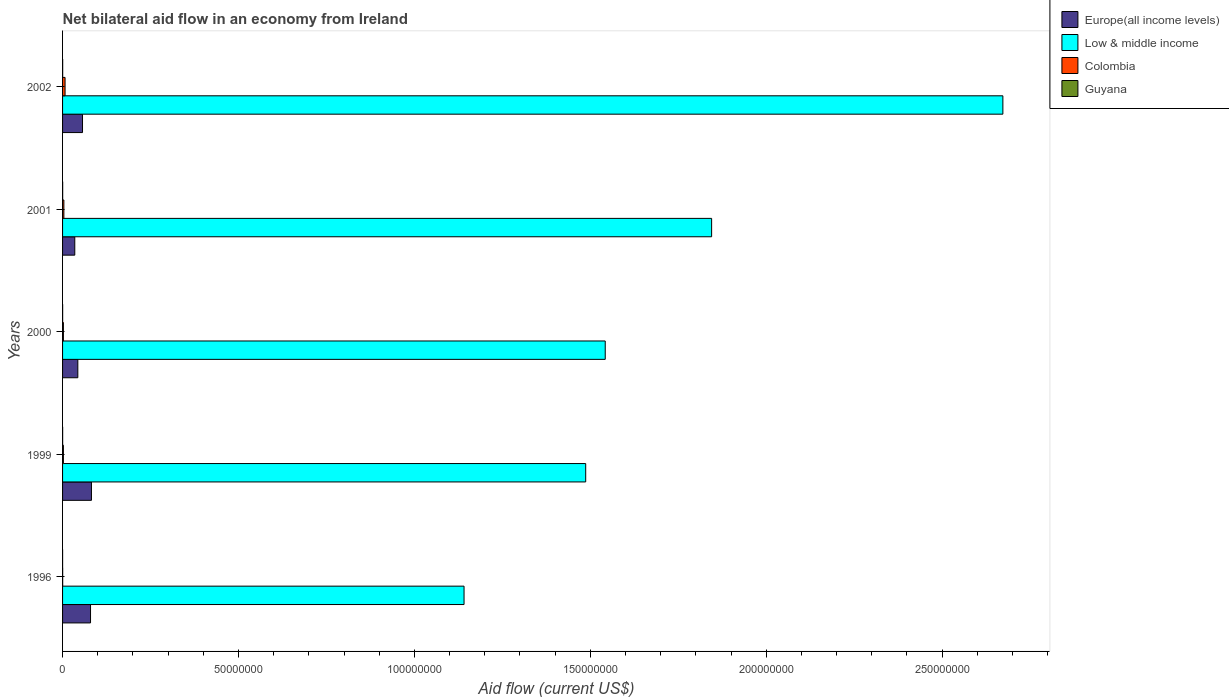How many different coloured bars are there?
Make the answer very short. 4. How many groups of bars are there?
Make the answer very short. 5. Are the number of bars on each tick of the Y-axis equal?
Provide a short and direct response. Yes. How many bars are there on the 2nd tick from the top?
Your answer should be compact. 4. In how many cases, is the number of bars for a given year not equal to the number of legend labels?
Make the answer very short. 0. What is the net bilateral aid flow in Europe(all income levels) in 1999?
Ensure brevity in your answer.  8.21e+06. Across all years, what is the maximum net bilateral aid flow in Low & middle income?
Provide a short and direct response. 2.67e+08. Across all years, what is the minimum net bilateral aid flow in Europe(all income levels)?
Offer a very short reply. 3.47e+06. In which year was the net bilateral aid flow in Guyana minimum?
Offer a terse response. 1996. What is the total net bilateral aid flow in Europe(all income levels) in the graph?
Provide a short and direct response. 2.96e+07. What is the difference between the net bilateral aid flow in Europe(all income levels) in 1996 and the net bilateral aid flow in Guyana in 2000?
Give a very brief answer. 7.93e+06. What is the average net bilateral aid flow in Guyana per year?
Offer a terse response. 2.20e+04. In the year 1999, what is the difference between the net bilateral aid flow in Guyana and net bilateral aid flow in Europe(all income levels)?
Give a very brief answer. -8.19e+06. What is the ratio of the net bilateral aid flow in Europe(all income levels) in 1999 to that in 2002?
Make the answer very short. 1.45. Is the net bilateral aid flow in Guyana in 1999 less than that in 2000?
Provide a short and direct response. No. What is the difference between the highest and the lowest net bilateral aid flow in Low & middle income?
Provide a succinct answer. 1.53e+08. In how many years, is the net bilateral aid flow in Low & middle income greater than the average net bilateral aid flow in Low & middle income taken over all years?
Make the answer very short. 2. Is the sum of the net bilateral aid flow in Europe(all income levels) in 1996 and 1999 greater than the maximum net bilateral aid flow in Colombia across all years?
Provide a short and direct response. Yes. How many bars are there?
Your answer should be compact. 20. What is the difference between two consecutive major ticks on the X-axis?
Give a very brief answer. 5.00e+07. Are the values on the major ticks of X-axis written in scientific E-notation?
Offer a terse response. No. What is the title of the graph?
Offer a very short reply. Net bilateral aid flow in an economy from Ireland. Does "Greenland" appear as one of the legend labels in the graph?
Your answer should be very brief. No. What is the label or title of the Y-axis?
Make the answer very short. Years. What is the Aid flow (current US$) of Europe(all income levels) in 1996?
Make the answer very short. 7.95e+06. What is the Aid flow (current US$) of Low & middle income in 1996?
Your answer should be compact. 1.14e+08. What is the Aid flow (current US$) of Guyana in 1996?
Offer a very short reply. 10000. What is the Aid flow (current US$) of Europe(all income levels) in 1999?
Offer a very short reply. 8.21e+06. What is the Aid flow (current US$) in Low & middle income in 1999?
Ensure brevity in your answer.  1.49e+08. What is the Aid flow (current US$) in Colombia in 1999?
Keep it short and to the point. 2.40e+05. What is the Aid flow (current US$) in Europe(all income levels) in 2000?
Your answer should be compact. 4.34e+06. What is the Aid flow (current US$) of Low & middle income in 2000?
Give a very brief answer. 1.54e+08. What is the Aid flow (current US$) of Europe(all income levels) in 2001?
Your answer should be very brief. 3.47e+06. What is the Aid flow (current US$) of Low & middle income in 2001?
Keep it short and to the point. 1.84e+08. What is the Aid flow (current US$) in Europe(all income levels) in 2002?
Keep it short and to the point. 5.67e+06. What is the Aid flow (current US$) in Low & middle income in 2002?
Ensure brevity in your answer.  2.67e+08. What is the Aid flow (current US$) in Colombia in 2002?
Your answer should be very brief. 7.10e+05. Across all years, what is the maximum Aid flow (current US$) in Europe(all income levels)?
Ensure brevity in your answer.  8.21e+06. Across all years, what is the maximum Aid flow (current US$) of Low & middle income?
Your answer should be compact. 2.67e+08. Across all years, what is the maximum Aid flow (current US$) of Colombia?
Your response must be concise. 7.10e+05. Across all years, what is the maximum Aid flow (current US$) of Guyana?
Ensure brevity in your answer.  3.00e+04. Across all years, what is the minimum Aid flow (current US$) in Europe(all income levels)?
Make the answer very short. 3.47e+06. Across all years, what is the minimum Aid flow (current US$) in Low & middle income?
Offer a very short reply. 1.14e+08. Across all years, what is the minimum Aid flow (current US$) in Colombia?
Make the answer very short. 3.00e+04. Across all years, what is the minimum Aid flow (current US$) of Guyana?
Provide a short and direct response. 10000. What is the total Aid flow (current US$) in Europe(all income levels) in the graph?
Your response must be concise. 2.96e+07. What is the total Aid flow (current US$) in Low & middle income in the graph?
Provide a succinct answer. 8.69e+08. What is the total Aid flow (current US$) in Colombia in the graph?
Your response must be concise. 1.59e+06. What is the total Aid flow (current US$) in Guyana in the graph?
Your answer should be compact. 1.10e+05. What is the difference between the Aid flow (current US$) of Europe(all income levels) in 1996 and that in 1999?
Your answer should be compact. -2.60e+05. What is the difference between the Aid flow (current US$) in Low & middle income in 1996 and that in 1999?
Your response must be concise. -3.46e+07. What is the difference between the Aid flow (current US$) of Europe(all income levels) in 1996 and that in 2000?
Provide a short and direct response. 3.61e+06. What is the difference between the Aid flow (current US$) of Low & middle income in 1996 and that in 2000?
Provide a short and direct response. -4.01e+07. What is the difference between the Aid flow (current US$) of Europe(all income levels) in 1996 and that in 2001?
Offer a very short reply. 4.48e+06. What is the difference between the Aid flow (current US$) in Low & middle income in 1996 and that in 2001?
Provide a succinct answer. -7.04e+07. What is the difference between the Aid flow (current US$) in Colombia in 1996 and that in 2001?
Ensure brevity in your answer.  -3.40e+05. What is the difference between the Aid flow (current US$) of Europe(all income levels) in 1996 and that in 2002?
Ensure brevity in your answer.  2.28e+06. What is the difference between the Aid flow (current US$) in Low & middle income in 1996 and that in 2002?
Give a very brief answer. -1.53e+08. What is the difference between the Aid flow (current US$) in Colombia in 1996 and that in 2002?
Your answer should be compact. -6.80e+05. What is the difference between the Aid flow (current US$) of Europe(all income levels) in 1999 and that in 2000?
Keep it short and to the point. 3.87e+06. What is the difference between the Aid flow (current US$) in Low & middle income in 1999 and that in 2000?
Keep it short and to the point. -5.55e+06. What is the difference between the Aid flow (current US$) of Europe(all income levels) in 1999 and that in 2001?
Make the answer very short. 4.74e+06. What is the difference between the Aid flow (current US$) in Low & middle income in 1999 and that in 2001?
Your answer should be compact. -3.58e+07. What is the difference between the Aid flow (current US$) of Colombia in 1999 and that in 2001?
Give a very brief answer. -1.30e+05. What is the difference between the Aid flow (current US$) of Europe(all income levels) in 1999 and that in 2002?
Your answer should be very brief. 2.54e+06. What is the difference between the Aid flow (current US$) of Low & middle income in 1999 and that in 2002?
Give a very brief answer. -1.19e+08. What is the difference between the Aid flow (current US$) in Colombia in 1999 and that in 2002?
Your answer should be very brief. -4.70e+05. What is the difference between the Aid flow (current US$) in Europe(all income levels) in 2000 and that in 2001?
Your answer should be compact. 8.70e+05. What is the difference between the Aid flow (current US$) of Low & middle income in 2000 and that in 2001?
Your answer should be very brief. -3.02e+07. What is the difference between the Aid flow (current US$) of Europe(all income levels) in 2000 and that in 2002?
Your response must be concise. -1.33e+06. What is the difference between the Aid flow (current US$) of Low & middle income in 2000 and that in 2002?
Your answer should be compact. -1.13e+08. What is the difference between the Aid flow (current US$) of Colombia in 2000 and that in 2002?
Your response must be concise. -4.70e+05. What is the difference between the Aid flow (current US$) in Europe(all income levels) in 2001 and that in 2002?
Ensure brevity in your answer.  -2.20e+06. What is the difference between the Aid flow (current US$) in Low & middle income in 2001 and that in 2002?
Provide a short and direct response. -8.28e+07. What is the difference between the Aid flow (current US$) of Colombia in 2001 and that in 2002?
Provide a succinct answer. -3.40e+05. What is the difference between the Aid flow (current US$) of Europe(all income levels) in 1996 and the Aid flow (current US$) of Low & middle income in 1999?
Give a very brief answer. -1.41e+08. What is the difference between the Aid flow (current US$) in Europe(all income levels) in 1996 and the Aid flow (current US$) in Colombia in 1999?
Offer a terse response. 7.71e+06. What is the difference between the Aid flow (current US$) in Europe(all income levels) in 1996 and the Aid flow (current US$) in Guyana in 1999?
Provide a succinct answer. 7.93e+06. What is the difference between the Aid flow (current US$) in Low & middle income in 1996 and the Aid flow (current US$) in Colombia in 1999?
Make the answer very short. 1.14e+08. What is the difference between the Aid flow (current US$) of Low & middle income in 1996 and the Aid flow (current US$) of Guyana in 1999?
Make the answer very short. 1.14e+08. What is the difference between the Aid flow (current US$) of Europe(all income levels) in 1996 and the Aid flow (current US$) of Low & middle income in 2000?
Ensure brevity in your answer.  -1.46e+08. What is the difference between the Aid flow (current US$) of Europe(all income levels) in 1996 and the Aid flow (current US$) of Colombia in 2000?
Your answer should be compact. 7.71e+06. What is the difference between the Aid flow (current US$) in Europe(all income levels) in 1996 and the Aid flow (current US$) in Guyana in 2000?
Provide a short and direct response. 7.93e+06. What is the difference between the Aid flow (current US$) in Low & middle income in 1996 and the Aid flow (current US$) in Colombia in 2000?
Provide a short and direct response. 1.14e+08. What is the difference between the Aid flow (current US$) in Low & middle income in 1996 and the Aid flow (current US$) in Guyana in 2000?
Provide a succinct answer. 1.14e+08. What is the difference between the Aid flow (current US$) of Colombia in 1996 and the Aid flow (current US$) of Guyana in 2000?
Keep it short and to the point. 10000. What is the difference between the Aid flow (current US$) in Europe(all income levels) in 1996 and the Aid flow (current US$) in Low & middle income in 2001?
Your answer should be compact. -1.77e+08. What is the difference between the Aid flow (current US$) in Europe(all income levels) in 1996 and the Aid flow (current US$) in Colombia in 2001?
Make the answer very short. 7.58e+06. What is the difference between the Aid flow (current US$) in Europe(all income levels) in 1996 and the Aid flow (current US$) in Guyana in 2001?
Provide a succinct answer. 7.92e+06. What is the difference between the Aid flow (current US$) in Low & middle income in 1996 and the Aid flow (current US$) in Colombia in 2001?
Make the answer very short. 1.14e+08. What is the difference between the Aid flow (current US$) of Low & middle income in 1996 and the Aid flow (current US$) of Guyana in 2001?
Provide a short and direct response. 1.14e+08. What is the difference between the Aid flow (current US$) in Colombia in 1996 and the Aid flow (current US$) in Guyana in 2001?
Give a very brief answer. 0. What is the difference between the Aid flow (current US$) in Europe(all income levels) in 1996 and the Aid flow (current US$) in Low & middle income in 2002?
Make the answer very short. -2.59e+08. What is the difference between the Aid flow (current US$) of Europe(all income levels) in 1996 and the Aid flow (current US$) of Colombia in 2002?
Offer a terse response. 7.24e+06. What is the difference between the Aid flow (current US$) of Europe(all income levels) in 1996 and the Aid flow (current US$) of Guyana in 2002?
Make the answer very short. 7.92e+06. What is the difference between the Aid flow (current US$) of Low & middle income in 1996 and the Aid flow (current US$) of Colombia in 2002?
Give a very brief answer. 1.13e+08. What is the difference between the Aid flow (current US$) in Low & middle income in 1996 and the Aid flow (current US$) in Guyana in 2002?
Give a very brief answer. 1.14e+08. What is the difference between the Aid flow (current US$) in Europe(all income levels) in 1999 and the Aid flow (current US$) in Low & middle income in 2000?
Ensure brevity in your answer.  -1.46e+08. What is the difference between the Aid flow (current US$) of Europe(all income levels) in 1999 and the Aid flow (current US$) of Colombia in 2000?
Provide a short and direct response. 7.97e+06. What is the difference between the Aid flow (current US$) of Europe(all income levels) in 1999 and the Aid flow (current US$) of Guyana in 2000?
Give a very brief answer. 8.19e+06. What is the difference between the Aid flow (current US$) of Low & middle income in 1999 and the Aid flow (current US$) of Colombia in 2000?
Keep it short and to the point. 1.48e+08. What is the difference between the Aid flow (current US$) in Low & middle income in 1999 and the Aid flow (current US$) in Guyana in 2000?
Offer a very short reply. 1.49e+08. What is the difference between the Aid flow (current US$) of Colombia in 1999 and the Aid flow (current US$) of Guyana in 2000?
Your response must be concise. 2.20e+05. What is the difference between the Aid flow (current US$) of Europe(all income levels) in 1999 and the Aid flow (current US$) of Low & middle income in 2001?
Your answer should be very brief. -1.76e+08. What is the difference between the Aid flow (current US$) of Europe(all income levels) in 1999 and the Aid flow (current US$) of Colombia in 2001?
Offer a terse response. 7.84e+06. What is the difference between the Aid flow (current US$) in Europe(all income levels) in 1999 and the Aid flow (current US$) in Guyana in 2001?
Ensure brevity in your answer.  8.18e+06. What is the difference between the Aid flow (current US$) in Low & middle income in 1999 and the Aid flow (current US$) in Colombia in 2001?
Provide a succinct answer. 1.48e+08. What is the difference between the Aid flow (current US$) in Low & middle income in 1999 and the Aid flow (current US$) in Guyana in 2001?
Provide a short and direct response. 1.49e+08. What is the difference between the Aid flow (current US$) of Europe(all income levels) in 1999 and the Aid flow (current US$) of Low & middle income in 2002?
Offer a terse response. -2.59e+08. What is the difference between the Aid flow (current US$) in Europe(all income levels) in 1999 and the Aid flow (current US$) in Colombia in 2002?
Your answer should be compact. 7.50e+06. What is the difference between the Aid flow (current US$) in Europe(all income levels) in 1999 and the Aid flow (current US$) in Guyana in 2002?
Offer a terse response. 8.18e+06. What is the difference between the Aid flow (current US$) of Low & middle income in 1999 and the Aid flow (current US$) of Colombia in 2002?
Offer a terse response. 1.48e+08. What is the difference between the Aid flow (current US$) in Low & middle income in 1999 and the Aid flow (current US$) in Guyana in 2002?
Offer a terse response. 1.49e+08. What is the difference between the Aid flow (current US$) in Europe(all income levels) in 2000 and the Aid flow (current US$) in Low & middle income in 2001?
Keep it short and to the point. -1.80e+08. What is the difference between the Aid flow (current US$) of Europe(all income levels) in 2000 and the Aid flow (current US$) of Colombia in 2001?
Give a very brief answer. 3.97e+06. What is the difference between the Aid flow (current US$) in Europe(all income levels) in 2000 and the Aid flow (current US$) in Guyana in 2001?
Offer a terse response. 4.31e+06. What is the difference between the Aid flow (current US$) in Low & middle income in 2000 and the Aid flow (current US$) in Colombia in 2001?
Give a very brief answer. 1.54e+08. What is the difference between the Aid flow (current US$) of Low & middle income in 2000 and the Aid flow (current US$) of Guyana in 2001?
Offer a very short reply. 1.54e+08. What is the difference between the Aid flow (current US$) in Europe(all income levels) in 2000 and the Aid flow (current US$) in Low & middle income in 2002?
Your response must be concise. -2.63e+08. What is the difference between the Aid flow (current US$) of Europe(all income levels) in 2000 and the Aid flow (current US$) of Colombia in 2002?
Make the answer very short. 3.63e+06. What is the difference between the Aid flow (current US$) of Europe(all income levels) in 2000 and the Aid flow (current US$) of Guyana in 2002?
Offer a very short reply. 4.31e+06. What is the difference between the Aid flow (current US$) in Low & middle income in 2000 and the Aid flow (current US$) in Colombia in 2002?
Your response must be concise. 1.54e+08. What is the difference between the Aid flow (current US$) in Low & middle income in 2000 and the Aid flow (current US$) in Guyana in 2002?
Ensure brevity in your answer.  1.54e+08. What is the difference between the Aid flow (current US$) in Europe(all income levels) in 2001 and the Aid flow (current US$) in Low & middle income in 2002?
Your response must be concise. -2.64e+08. What is the difference between the Aid flow (current US$) of Europe(all income levels) in 2001 and the Aid flow (current US$) of Colombia in 2002?
Your response must be concise. 2.76e+06. What is the difference between the Aid flow (current US$) of Europe(all income levels) in 2001 and the Aid flow (current US$) of Guyana in 2002?
Your answer should be very brief. 3.44e+06. What is the difference between the Aid flow (current US$) in Low & middle income in 2001 and the Aid flow (current US$) in Colombia in 2002?
Your answer should be compact. 1.84e+08. What is the difference between the Aid flow (current US$) of Low & middle income in 2001 and the Aid flow (current US$) of Guyana in 2002?
Give a very brief answer. 1.84e+08. What is the difference between the Aid flow (current US$) in Colombia in 2001 and the Aid flow (current US$) in Guyana in 2002?
Keep it short and to the point. 3.40e+05. What is the average Aid flow (current US$) in Europe(all income levels) per year?
Your answer should be compact. 5.93e+06. What is the average Aid flow (current US$) of Low & middle income per year?
Offer a terse response. 1.74e+08. What is the average Aid flow (current US$) of Colombia per year?
Make the answer very short. 3.18e+05. What is the average Aid flow (current US$) of Guyana per year?
Your answer should be compact. 2.20e+04. In the year 1996, what is the difference between the Aid flow (current US$) in Europe(all income levels) and Aid flow (current US$) in Low & middle income?
Make the answer very short. -1.06e+08. In the year 1996, what is the difference between the Aid flow (current US$) in Europe(all income levels) and Aid flow (current US$) in Colombia?
Offer a terse response. 7.92e+06. In the year 1996, what is the difference between the Aid flow (current US$) in Europe(all income levels) and Aid flow (current US$) in Guyana?
Your answer should be compact. 7.94e+06. In the year 1996, what is the difference between the Aid flow (current US$) of Low & middle income and Aid flow (current US$) of Colombia?
Make the answer very short. 1.14e+08. In the year 1996, what is the difference between the Aid flow (current US$) in Low & middle income and Aid flow (current US$) in Guyana?
Ensure brevity in your answer.  1.14e+08. In the year 1999, what is the difference between the Aid flow (current US$) of Europe(all income levels) and Aid flow (current US$) of Low & middle income?
Keep it short and to the point. -1.40e+08. In the year 1999, what is the difference between the Aid flow (current US$) of Europe(all income levels) and Aid flow (current US$) of Colombia?
Provide a short and direct response. 7.97e+06. In the year 1999, what is the difference between the Aid flow (current US$) in Europe(all income levels) and Aid flow (current US$) in Guyana?
Offer a very short reply. 8.19e+06. In the year 1999, what is the difference between the Aid flow (current US$) in Low & middle income and Aid flow (current US$) in Colombia?
Give a very brief answer. 1.48e+08. In the year 1999, what is the difference between the Aid flow (current US$) in Low & middle income and Aid flow (current US$) in Guyana?
Offer a very short reply. 1.49e+08. In the year 2000, what is the difference between the Aid flow (current US$) in Europe(all income levels) and Aid flow (current US$) in Low & middle income?
Your answer should be very brief. -1.50e+08. In the year 2000, what is the difference between the Aid flow (current US$) of Europe(all income levels) and Aid flow (current US$) of Colombia?
Keep it short and to the point. 4.10e+06. In the year 2000, what is the difference between the Aid flow (current US$) in Europe(all income levels) and Aid flow (current US$) in Guyana?
Make the answer very short. 4.32e+06. In the year 2000, what is the difference between the Aid flow (current US$) of Low & middle income and Aid flow (current US$) of Colombia?
Your response must be concise. 1.54e+08. In the year 2000, what is the difference between the Aid flow (current US$) in Low & middle income and Aid flow (current US$) in Guyana?
Provide a succinct answer. 1.54e+08. In the year 2001, what is the difference between the Aid flow (current US$) of Europe(all income levels) and Aid flow (current US$) of Low & middle income?
Offer a terse response. -1.81e+08. In the year 2001, what is the difference between the Aid flow (current US$) of Europe(all income levels) and Aid flow (current US$) of Colombia?
Ensure brevity in your answer.  3.10e+06. In the year 2001, what is the difference between the Aid flow (current US$) in Europe(all income levels) and Aid flow (current US$) in Guyana?
Keep it short and to the point. 3.44e+06. In the year 2001, what is the difference between the Aid flow (current US$) in Low & middle income and Aid flow (current US$) in Colombia?
Offer a very short reply. 1.84e+08. In the year 2001, what is the difference between the Aid flow (current US$) in Low & middle income and Aid flow (current US$) in Guyana?
Your answer should be very brief. 1.84e+08. In the year 2002, what is the difference between the Aid flow (current US$) of Europe(all income levels) and Aid flow (current US$) of Low & middle income?
Your answer should be compact. -2.62e+08. In the year 2002, what is the difference between the Aid flow (current US$) of Europe(all income levels) and Aid flow (current US$) of Colombia?
Keep it short and to the point. 4.96e+06. In the year 2002, what is the difference between the Aid flow (current US$) of Europe(all income levels) and Aid flow (current US$) of Guyana?
Your response must be concise. 5.64e+06. In the year 2002, what is the difference between the Aid flow (current US$) in Low & middle income and Aid flow (current US$) in Colombia?
Your response must be concise. 2.67e+08. In the year 2002, what is the difference between the Aid flow (current US$) in Low & middle income and Aid flow (current US$) in Guyana?
Provide a succinct answer. 2.67e+08. In the year 2002, what is the difference between the Aid flow (current US$) of Colombia and Aid flow (current US$) of Guyana?
Offer a very short reply. 6.80e+05. What is the ratio of the Aid flow (current US$) of Europe(all income levels) in 1996 to that in 1999?
Offer a terse response. 0.97. What is the ratio of the Aid flow (current US$) in Low & middle income in 1996 to that in 1999?
Offer a terse response. 0.77. What is the ratio of the Aid flow (current US$) of Europe(all income levels) in 1996 to that in 2000?
Keep it short and to the point. 1.83. What is the ratio of the Aid flow (current US$) of Low & middle income in 1996 to that in 2000?
Offer a terse response. 0.74. What is the ratio of the Aid flow (current US$) of Colombia in 1996 to that in 2000?
Your answer should be compact. 0.12. What is the ratio of the Aid flow (current US$) of Guyana in 1996 to that in 2000?
Your answer should be compact. 0.5. What is the ratio of the Aid flow (current US$) of Europe(all income levels) in 1996 to that in 2001?
Keep it short and to the point. 2.29. What is the ratio of the Aid flow (current US$) of Low & middle income in 1996 to that in 2001?
Keep it short and to the point. 0.62. What is the ratio of the Aid flow (current US$) of Colombia in 1996 to that in 2001?
Provide a succinct answer. 0.08. What is the ratio of the Aid flow (current US$) of Guyana in 1996 to that in 2001?
Make the answer very short. 0.33. What is the ratio of the Aid flow (current US$) in Europe(all income levels) in 1996 to that in 2002?
Your response must be concise. 1.4. What is the ratio of the Aid flow (current US$) of Low & middle income in 1996 to that in 2002?
Keep it short and to the point. 0.43. What is the ratio of the Aid flow (current US$) in Colombia in 1996 to that in 2002?
Make the answer very short. 0.04. What is the ratio of the Aid flow (current US$) of Europe(all income levels) in 1999 to that in 2000?
Your answer should be very brief. 1.89. What is the ratio of the Aid flow (current US$) in Low & middle income in 1999 to that in 2000?
Provide a short and direct response. 0.96. What is the ratio of the Aid flow (current US$) of Guyana in 1999 to that in 2000?
Give a very brief answer. 1. What is the ratio of the Aid flow (current US$) of Europe(all income levels) in 1999 to that in 2001?
Ensure brevity in your answer.  2.37. What is the ratio of the Aid flow (current US$) in Low & middle income in 1999 to that in 2001?
Ensure brevity in your answer.  0.81. What is the ratio of the Aid flow (current US$) in Colombia in 1999 to that in 2001?
Provide a succinct answer. 0.65. What is the ratio of the Aid flow (current US$) in Guyana in 1999 to that in 2001?
Your answer should be very brief. 0.67. What is the ratio of the Aid flow (current US$) in Europe(all income levels) in 1999 to that in 2002?
Make the answer very short. 1.45. What is the ratio of the Aid flow (current US$) in Low & middle income in 1999 to that in 2002?
Make the answer very short. 0.56. What is the ratio of the Aid flow (current US$) in Colombia in 1999 to that in 2002?
Give a very brief answer. 0.34. What is the ratio of the Aid flow (current US$) of Guyana in 1999 to that in 2002?
Your answer should be compact. 0.67. What is the ratio of the Aid flow (current US$) of Europe(all income levels) in 2000 to that in 2001?
Your answer should be very brief. 1.25. What is the ratio of the Aid flow (current US$) of Low & middle income in 2000 to that in 2001?
Keep it short and to the point. 0.84. What is the ratio of the Aid flow (current US$) in Colombia in 2000 to that in 2001?
Your answer should be compact. 0.65. What is the ratio of the Aid flow (current US$) of Europe(all income levels) in 2000 to that in 2002?
Keep it short and to the point. 0.77. What is the ratio of the Aid flow (current US$) in Low & middle income in 2000 to that in 2002?
Give a very brief answer. 0.58. What is the ratio of the Aid flow (current US$) in Colombia in 2000 to that in 2002?
Your response must be concise. 0.34. What is the ratio of the Aid flow (current US$) in Guyana in 2000 to that in 2002?
Your answer should be very brief. 0.67. What is the ratio of the Aid flow (current US$) of Europe(all income levels) in 2001 to that in 2002?
Keep it short and to the point. 0.61. What is the ratio of the Aid flow (current US$) in Low & middle income in 2001 to that in 2002?
Make the answer very short. 0.69. What is the ratio of the Aid flow (current US$) of Colombia in 2001 to that in 2002?
Your answer should be very brief. 0.52. What is the difference between the highest and the second highest Aid flow (current US$) of Europe(all income levels)?
Ensure brevity in your answer.  2.60e+05. What is the difference between the highest and the second highest Aid flow (current US$) of Low & middle income?
Provide a short and direct response. 8.28e+07. What is the difference between the highest and the second highest Aid flow (current US$) of Colombia?
Your answer should be very brief. 3.40e+05. What is the difference between the highest and the lowest Aid flow (current US$) in Europe(all income levels)?
Ensure brevity in your answer.  4.74e+06. What is the difference between the highest and the lowest Aid flow (current US$) of Low & middle income?
Provide a succinct answer. 1.53e+08. What is the difference between the highest and the lowest Aid flow (current US$) in Colombia?
Provide a short and direct response. 6.80e+05. What is the difference between the highest and the lowest Aid flow (current US$) in Guyana?
Keep it short and to the point. 2.00e+04. 